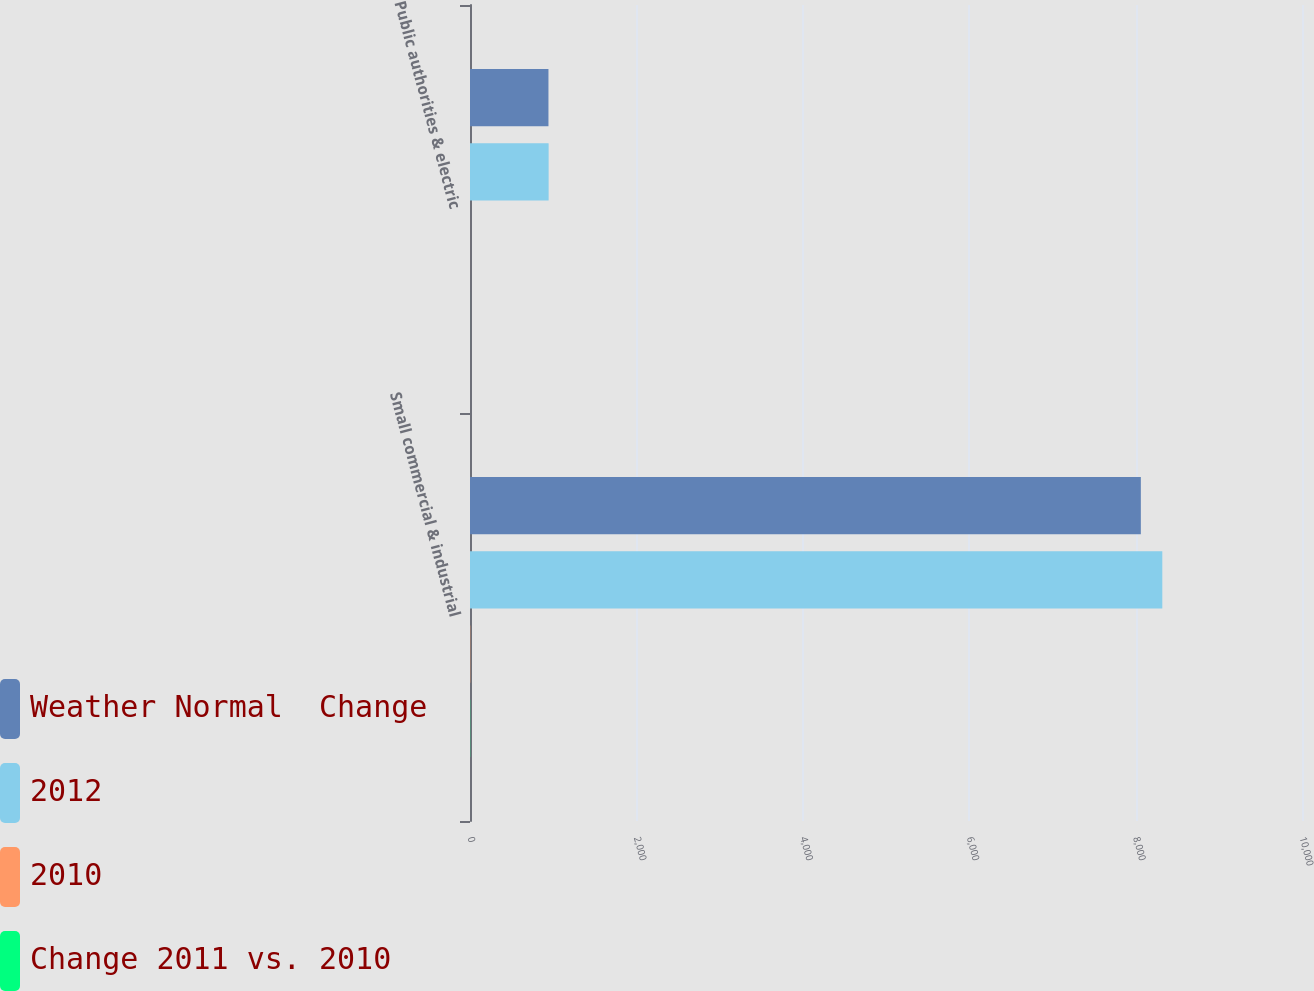Convert chart. <chart><loc_0><loc_0><loc_500><loc_500><stacked_bar_chart><ecel><fcel>Small commercial & industrial<fcel>Public authorities & electric<nl><fcel>Weather Normal  Change<fcel>8063<fcel>943<nl><fcel>2012<fcel>8321<fcel>945<nl><fcel>2010<fcel>3.1<fcel>0.2<nl><fcel>Change 2011 vs. 2010<fcel>2.3<fcel>0.2<nl></chart> 